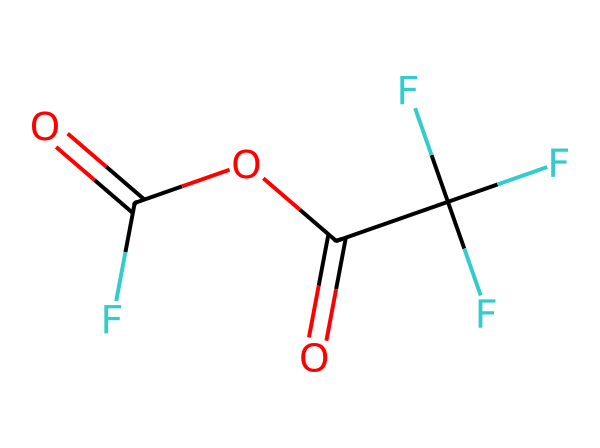What is the molecular formula of trifluoroacetic anhydride? By analyzing the SMILES representation, one can identify the elements present: carbon (C), oxygen (O), and fluorine (F). Counting the atoms gives: 4 carbon atoms, 4 oxygen atoms, and 3 fluorine atoms. Thus, the molecular formula is compiled as C4H2F3O3.
Answer: C4H2F3O3 How many oxygen atoms are in this structure? From the SMILES representation, the oxygen atoms are represented as 'O'. Upon inspection, there are four 'O' symbols present within the structure, indicating the presence of four oxygen atoms overall.
Answer: 4 What type of functional groups are present in trifluoroacetic anhydride? The structure contains acyl groups indicated by the C(=O) shorthand. This illustrates that there are two acyl functional groups due to the presence of two carbonyls (C=O) in the anhydride formation.
Answer: anhydride How many total atoms are present in this molecule? After identifying the atoms from the molecular structure: 4 carbon atoms, 2 hydrogen atoms, 3 fluorine atoms, and 4 oxygen atoms, when summed together, it results in a total of 13 atoms in the molecule.
Answer: 13 What type of bonding is implied by the C=O units? The presence of C=O indicates double bonds, characteristic of carbonyl groups, which are typical in acid anhydrides. Each carbonyl group involves double-bonded interactions significant for their chemistry and reactivity.
Answer: double bond Is trifluoroacetic anhydride an example of a symmetrical or asymmetrical anhydride? By analyzing the structure, both acyl groups derived from trifluoroacetic acid are identical, thus characterizing trifluoroacetic anhydride as a symmetrical anhydride.
Answer: symmetrical 